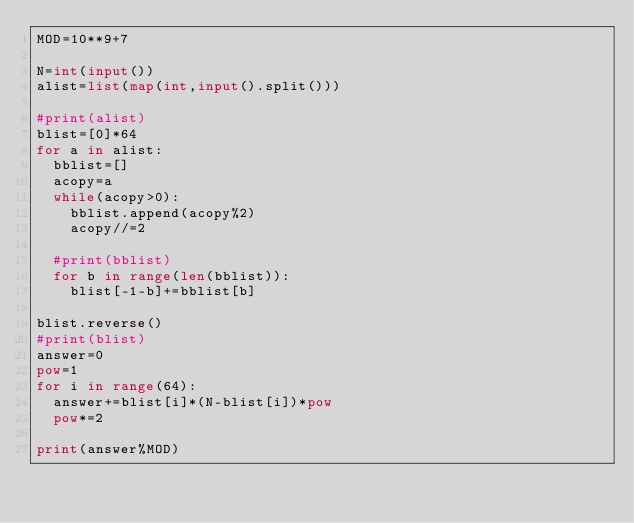Convert code to text. <code><loc_0><loc_0><loc_500><loc_500><_Python_>MOD=10**9+7

N=int(input())
alist=list(map(int,input().split()))

#print(alist)
blist=[0]*64
for a in alist:
  bblist=[]
  acopy=a
  while(acopy>0):
    bblist.append(acopy%2)
    acopy//=2
    
  #print(bblist)
  for b in range(len(bblist)):
    blist[-1-b]+=bblist[b]
      
blist.reverse()
#print(blist)
answer=0
pow=1
for i in range(64):
  answer+=blist[i]*(N-blist[i])*pow
  pow*=2
  
print(answer%MOD)</code> 